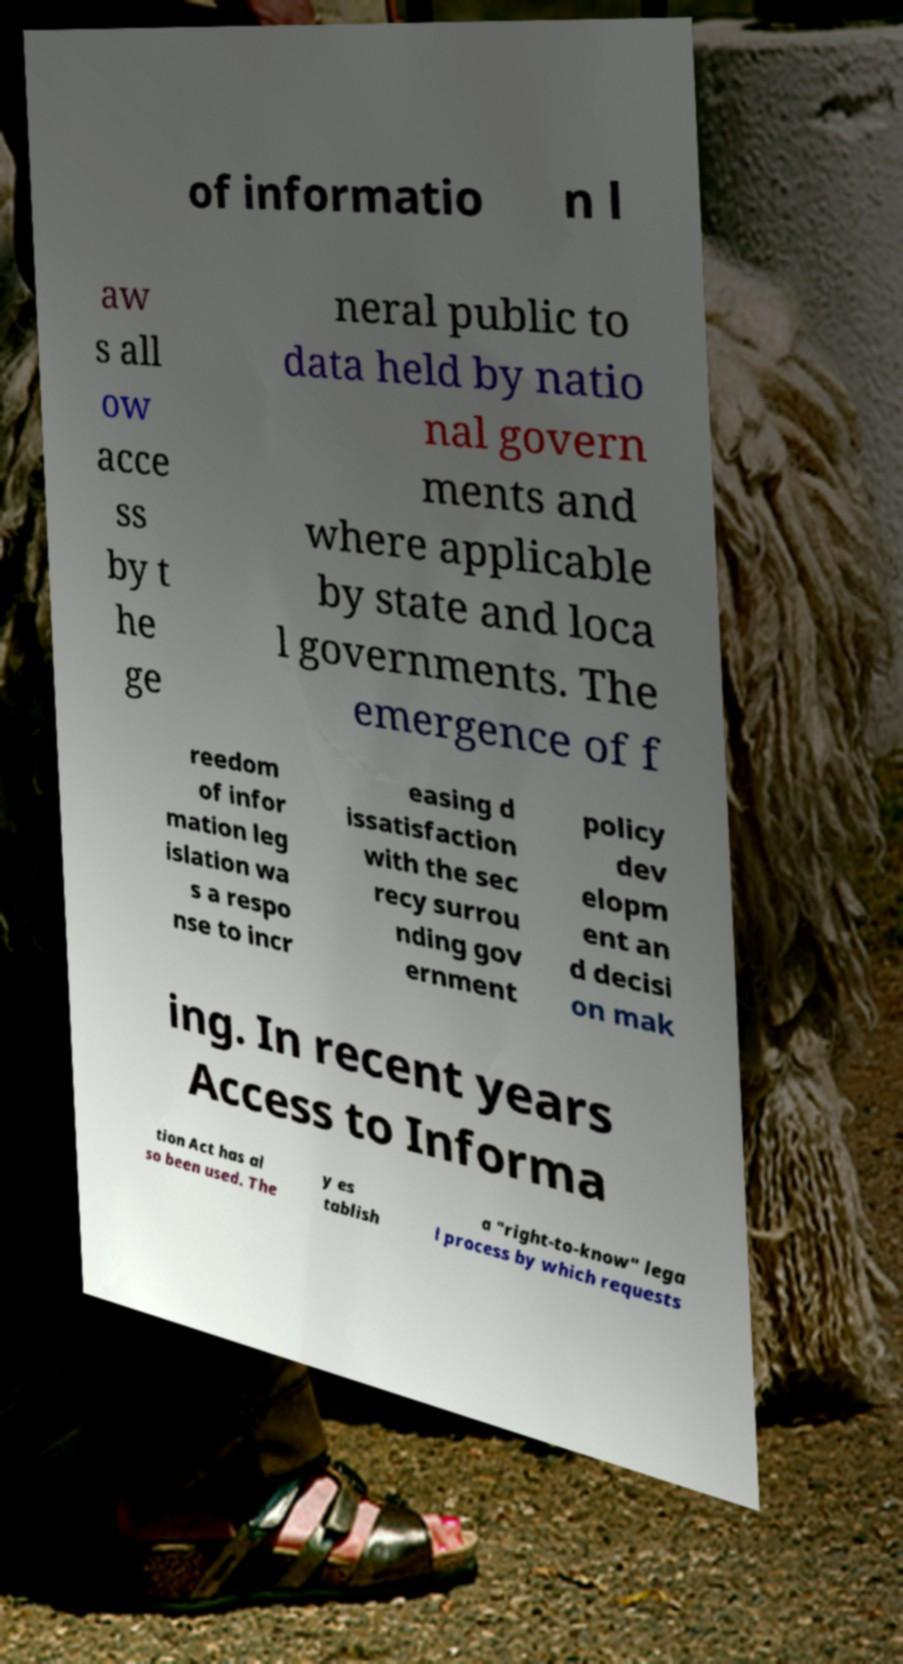Could you assist in decoding the text presented in this image and type it out clearly? of informatio n l aw s all ow acce ss by t he ge neral public to data held by natio nal govern ments and where applicable by state and loca l governments. The emergence of f reedom of infor mation leg islation wa s a respo nse to incr easing d issatisfaction with the sec recy surrou nding gov ernment policy dev elopm ent an d decisi on mak ing. In recent years Access to Informa tion Act has al so been used. The y es tablish a "right-to-know" lega l process by which requests 